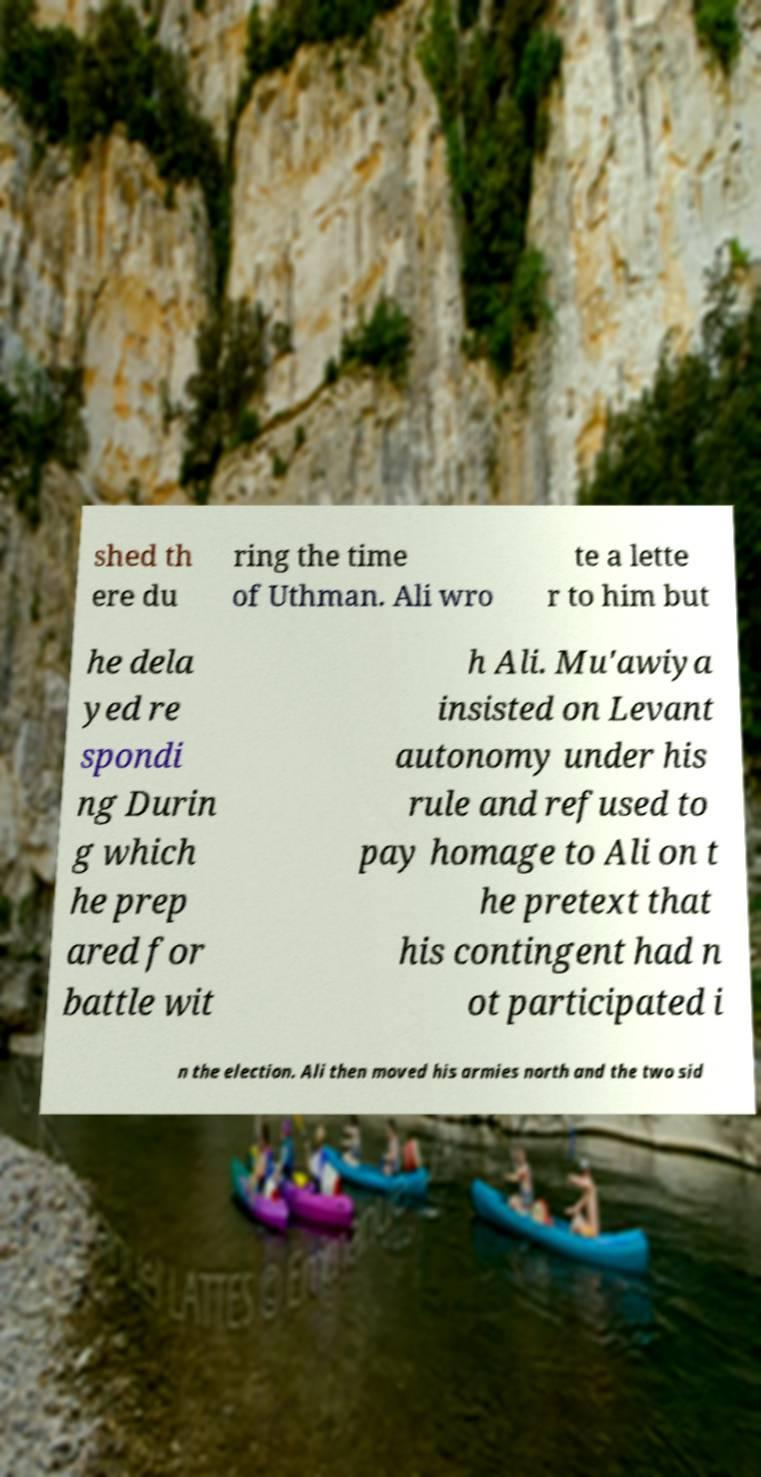Could you assist in decoding the text presented in this image and type it out clearly? shed th ere du ring the time of Uthman. Ali wro te a lette r to him but he dela yed re spondi ng Durin g which he prep ared for battle wit h Ali. Mu'awiya insisted on Levant autonomy under his rule and refused to pay homage to Ali on t he pretext that his contingent had n ot participated i n the election. Ali then moved his armies north and the two sid 